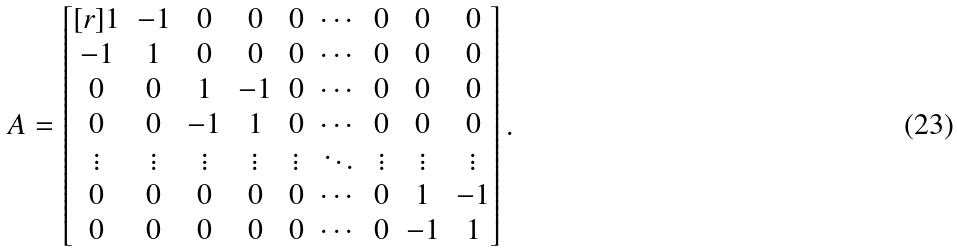Convert formula to latex. <formula><loc_0><loc_0><loc_500><loc_500>A = \begin{bmatrix} [ r ] 1 & - 1 & 0 & 0 & 0 & \cdots & 0 & 0 & 0 \\ - 1 & 1 & 0 & 0 & 0 & \cdots & 0 & 0 & 0 \\ 0 & 0 & 1 & - 1 & 0 & \cdots & 0 & 0 & 0 \\ 0 & 0 & - 1 & 1 & 0 & \cdots & 0 & 0 & 0 \\ \vdots & \vdots & \vdots & \vdots & \vdots & \ddots & \vdots & \vdots & \vdots \\ 0 & 0 & 0 & 0 & 0 & \cdots & 0 & 1 & - 1 \\ 0 & 0 & 0 & 0 & 0 & \cdots & 0 & - 1 & 1 \end{bmatrix} .</formula> 